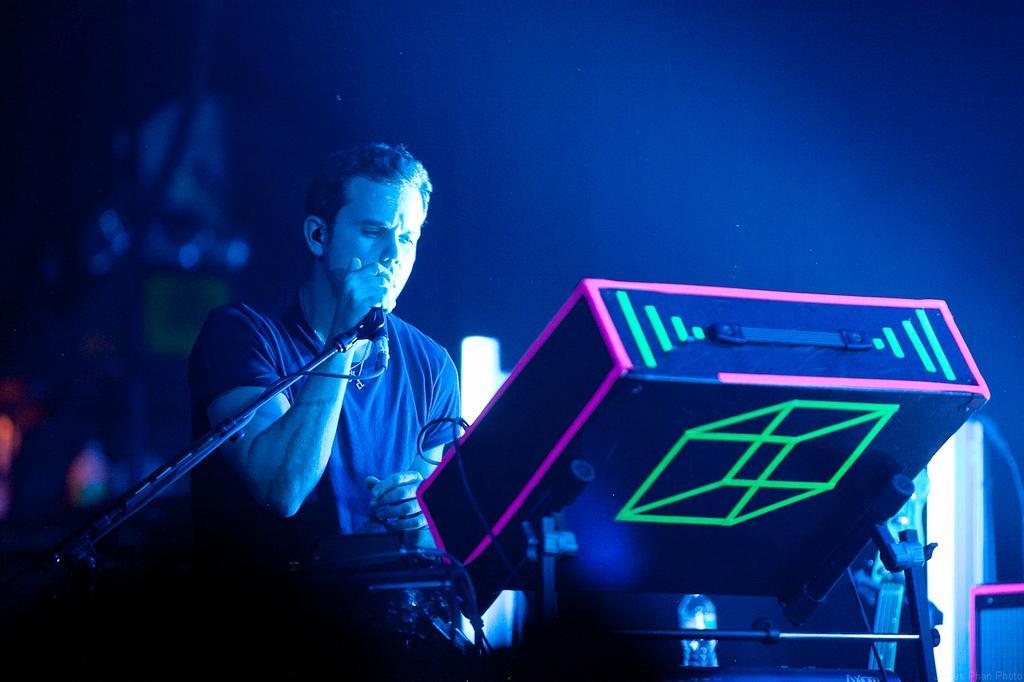In one or two sentences, can you explain what this image depicts? In this picture, we can see a person holding a microphone with a stand, and we can see some objects on the right side of the picture, like a box, wires, and we can see the blurred background. 